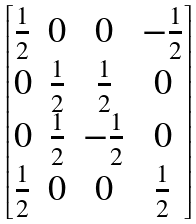<formula> <loc_0><loc_0><loc_500><loc_500>\begin{bmatrix} \frac { 1 } { 2 } & 0 & 0 & - \frac { 1 } { 2 } \\ 0 & \frac { 1 } { 2 } & \frac { 1 } { 2 } & 0 \\ 0 & \frac { 1 } { 2 } & - \frac { 1 } { 2 } & 0 \\ \frac { 1 } { 2 } & 0 & 0 & \frac { 1 } { 2 } \end{bmatrix}</formula> 